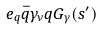Convert formula to latex. <formula><loc_0><loc_0><loc_500><loc_500>e _ { q } \bar { q } \gamma _ { \nu } q G _ { \gamma } ( s ^ { \prime } ) \</formula> 